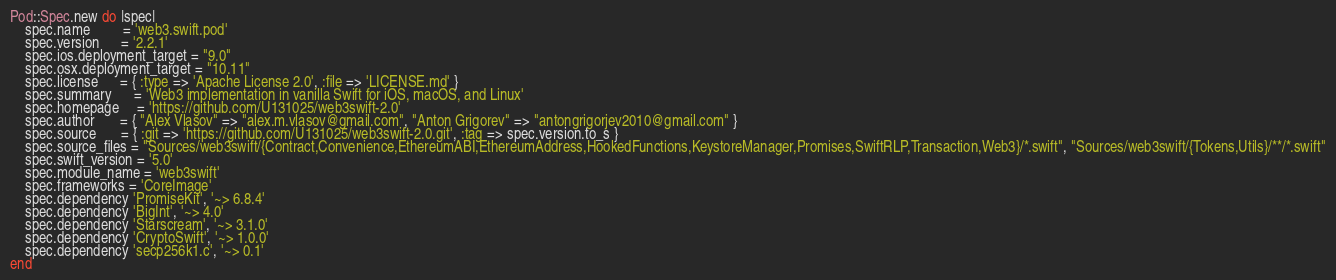<code> <loc_0><loc_0><loc_500><loc_500><_Ruby_>Pod::Spec.new do |spec|
    spec.name         = 'web3.swift.pod'
    spec.version      = '2.2.1'
    spec.ios.deployment_target = "9.0"
    spec.osx.deployment_target = "10.11"
    spec.license      = { :type => 'Apache License 2.0', :file => 'LICENSE.md' }
    spec.summary      = 'Web3 implementation in vanilla Swift for iOS, macOS, and Linux'
    spec.homepage     = 'https://github.com/U131025/web3swift-2.0'
    spec.author       = { "Alex Vlasov" => "alex.m.vlasov@gmail.com", "Anton Grigorev" => "antongrigorjev2010@gmail.com" }
    spec.source       = { :git => 'https://github.com/U131025/web3swift-2.0.git', :tag => spec.version.to_s }
    spec.source_files = "Sources/web3swift/{Contract,Convenience,EthereumABI,EthereumAddress,HookedFunctions,KeystoreManager,Promises,SwiftRLP,Transaction,Web3}/*.swift", "Sources/web3swift/{Tokens,Utils}/**/*.swift"
    spec.swift_version = '5.0'
    spec.module_name = 'web3swift'
    spec.frameworks = 'CoreImage'
    spec.dependency 'PromiseKit', '~> 6.8.4'
    spec.dependency 'BigInt', '~> 4.0'
    spec.dependency 'Starscream', '~> 3.1.0'
    spec.dependency 'CryptoSwift', '~> 1.0.0'
    spec.dependency 'secp256k1.c', '~> 0.1'
end
</code> 